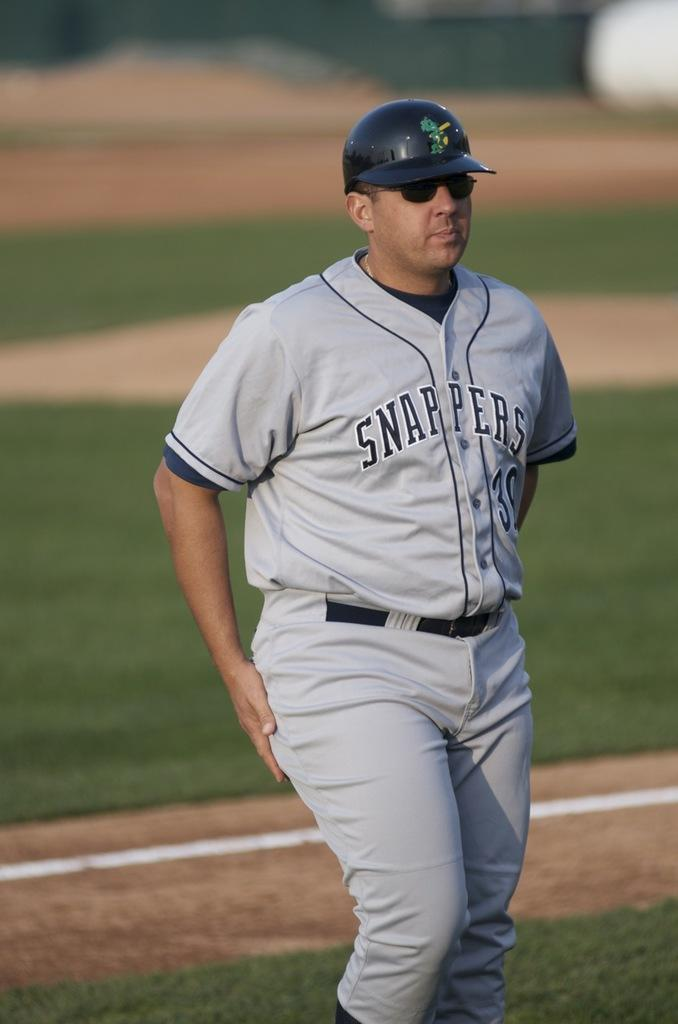<image>
Give a short and clear explanation of the subsequent image. A Snappers baseball player walks off the field wearing sunglasses. 